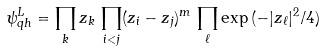Convert formula to latex. <formula><loc_0><loc_0><loc_500><loc_500>\psi _ { q h } ^ { L } = \prod _ { k } z _ { k } \, \prod _ { i < j } ( z _ { i } - z _ { j } ) ^ { m } \, \prod _ { \ell } \exp { ( - | z _ { \ell } | ^ { 2 } / 4 ) }</formula> 